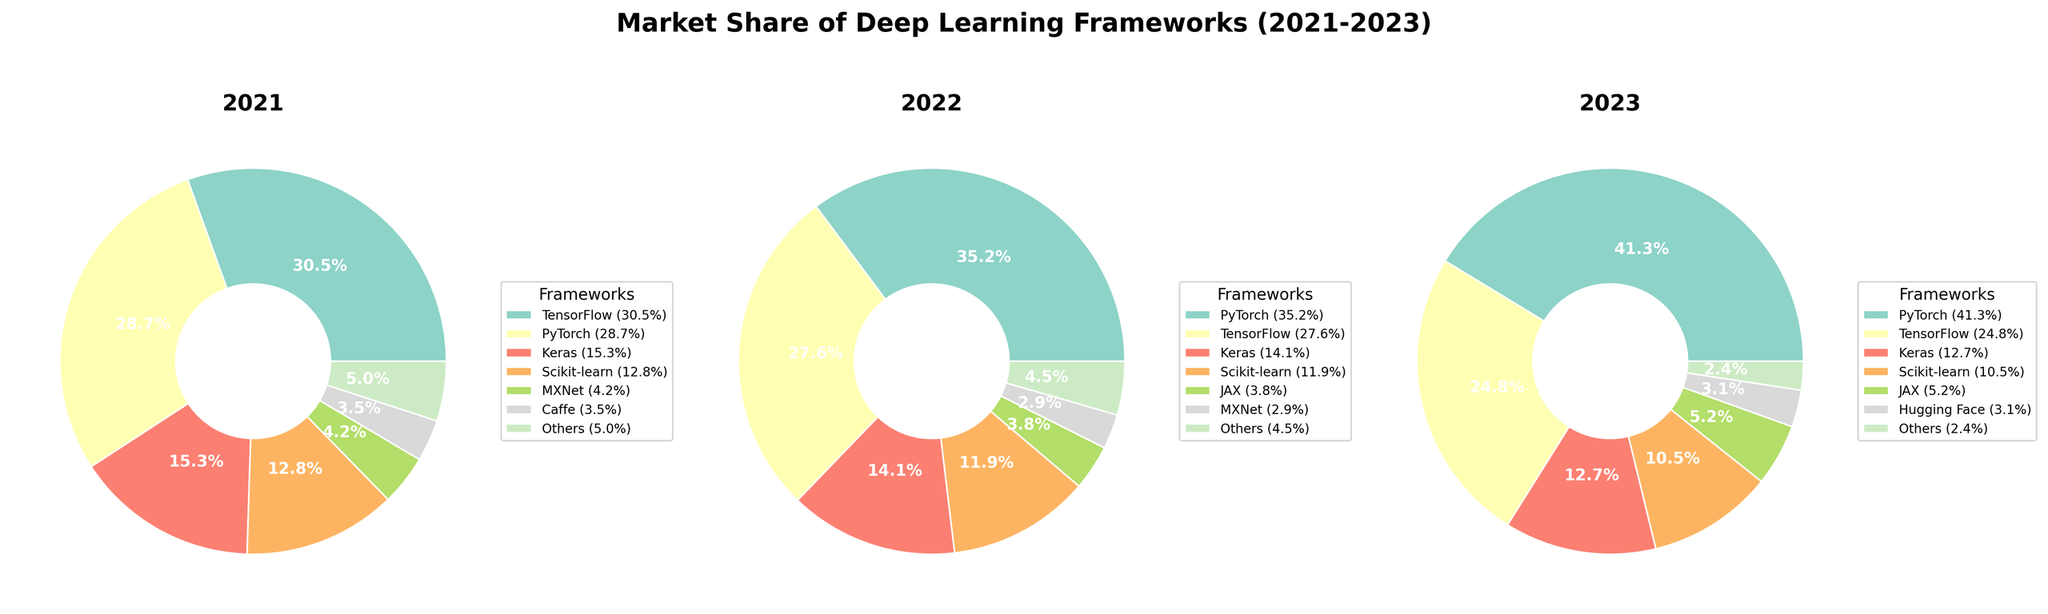What is the market share of PyTorch in 2023? To find the market share of PyTorch in 2023, look at the slice labeled "PyTorch" in the pie chart for 2023. The label indicates the percentage.
Answer: 41.3% Which framework's market share increased the most from 2021 to 2023? Compare the slices of each framework across the three years. PyTorch increased from 28.7% in 2021 to 41.3% in 2023, a difference of 12.6%, which is the largest increase.
Answer: PyTorch How did the market share of TensorFlow change from 2021 to 2023? Compare the market share of TensorFlow in the 2021 pie chart with the 2023 pie chart. In 2021, it was 30.5%, and in 2023, it was 24.8%. The change is 30.5% - 24.8% = -5.7%.
Answer: Decreased by 5.7% Which framework had the lowest market share in 2022 and what was its value? Look for the framework with the smallest slice in the 2022 pie chart. MXNet had the smallest percentage at 2.9%.
Answer: MXNet with 2.9% What is the combined market share of Keras and Scikit-learn in 2021? Add the percentages of Keras and Scikit-learn in the 2021 pie chart. Keras has 15.3% and Scikit-learn has 12.8%. So, 15.3% + 12.8% = 28.1%.
Answer: 28.1% Which framework first appeared in the dataset in 2023? Identify any new frameworks in the 2023 pie chart that weren't present in previous years. Hugging Face appears for the first time in 2023.
Answer: Hugging Face In which year did PyTorch surpass TensorFlow in market share? Compare the market share of PyTorch and TensorFlow across 2021, 2022, and 2023. In 2022, PyTorch (35.2%) surpassed TensorFlow (27.6%) for the first time.
Answer: 2022 What visual attribute is used to differentiate the frameworks in the pie charts? Observe the characteristics that help identify different frameworks. The pie slices use different colors to distinguish frameworks.
Answer: Color 